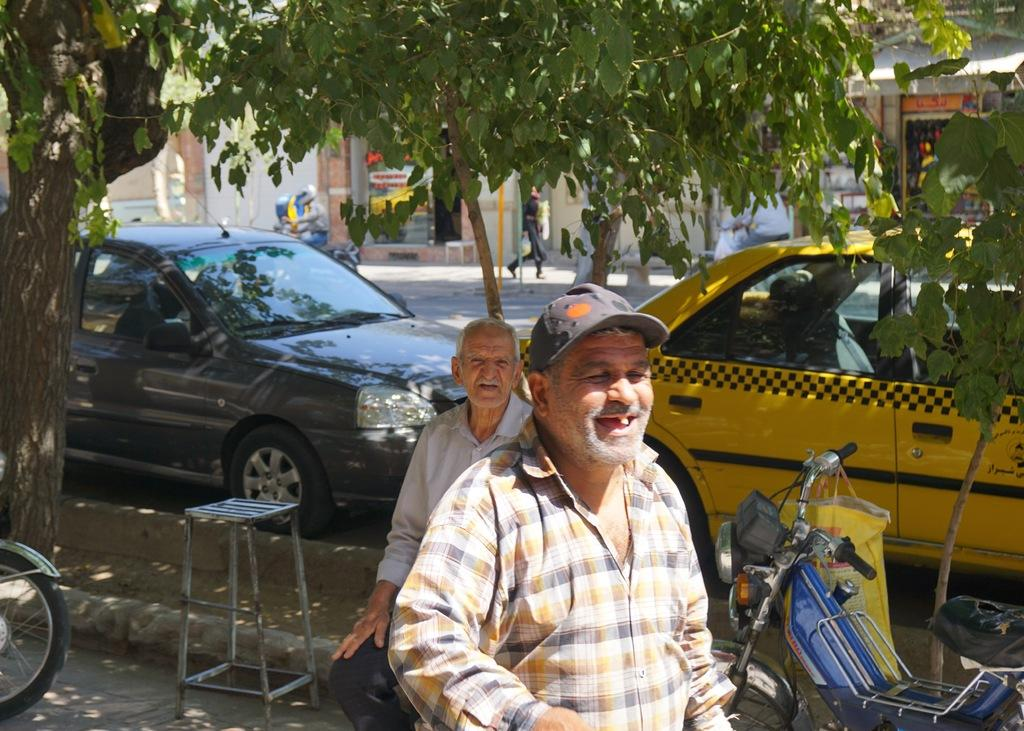Who is present in the image? There is a man in the image. What is the man wearing on his upper body? The man is wearing a shirt. What is the man wearing on his head? The man is wearing a cap. How many cars can be seen on the road in the image? There are two cars on the road in the image. What type of vegetation is on the left side of the image? There is a tree on the left side of the image. What type of account does the man have in the image? There is no mention of an account in the image; it features a man wearing a shirt and cap, two cars on the road, and a tree on the left side. Is there a crown visible on the man's head in the image? No, the man is wearing a cap, not a crown, in the image. 